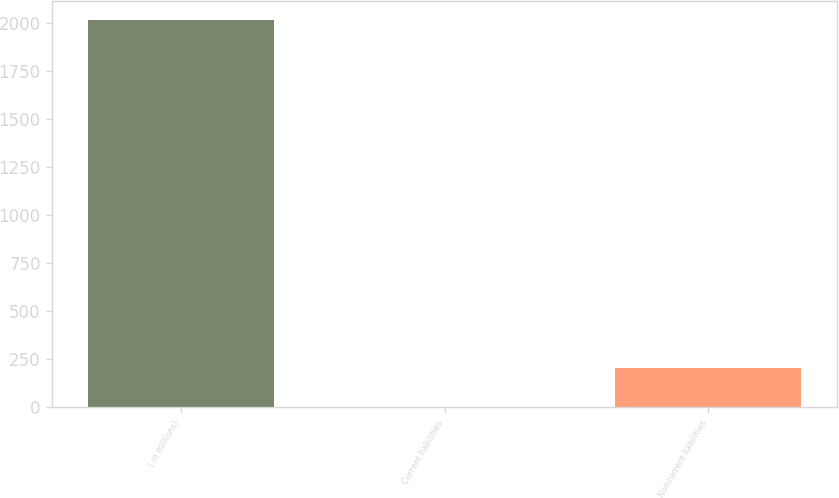Convert chart. <chart><loc_0><loc_0><loc_500><loc_500><bar_chart><fcel>( in millions)<fcel>Current liabilities<fcel>Noncurrent liabilities<nl><fcel>2017<fcel>1.5<fcel>203.05<nl></chart> 